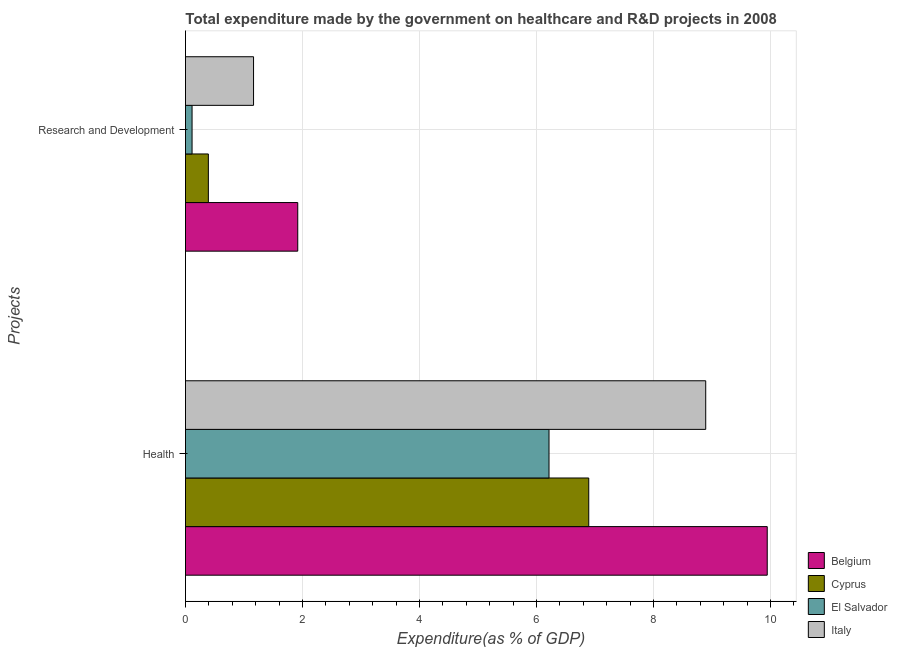How many groups of bars are there?
Offer a very short reply. 2. How many bars are there on the 2nd tick from the top?
Offer a very short reply. 4. How many bars are there on the 2nd tick from the bottom?
Provide a short and direct response. 4. What is the label of the 2nd group of bars from the top?
Your answer should be very brief. Health. What is the expenditure in healthcare in Belgium?
Make the answer very short. 9.94. Across all countries, what is the maximum expenditure in healthcare?
Your answer should be very brief. 9.94. Across all countries, what is the minimum expenditure in r&d?
Your response must be concise. 0.11. In which country was the expenditure in r&d maximum?
Give a very brief answer. Belgium. In which country was the expenditure in healthcare minimum?
Your answer should be compact. El Salvador. What is the total expenditure in healthcare in the graph?
Give a very brief answer. 31.94. What is the difference between the expenditure in r&d in Cyprus and that in Italy?
Keep it short and to the point. -0.77. What is the difference between the expenditure in healthcare in Cyprus and the expenditure in r&d in Belgium?
Your answer should be compact. 4.97. What is the average expenditure in healthcare per country?
Ensure brevity in your answer.  7.98. What is the difference between the expenditure in healthcare and expenditure in r&d in Belgium?
Provide a succinct answer. 8.02. In how many countries, is the expenditure in healthcare greater than 6 %?
Offer a terse response. 4. What is the ratio of the expenditure in r&d in Cyprus to that in Italy?
Give a very brief answer. 0.34. Is the expenditure in healthcare in Belgium less than that in Cyprus?
Make the answer very short. No. In how many countries, is the expenditure in healthcare greater than the average expenditure in healthcare taken over all countries?
Offer a terse response. 2. What does the 4th bar from the top in Research and Development represents?
Offer a very short reply. Belgium. What does the 1st bar from the bottom in Health represents?
Keep it short and to the point. Belgium. How many bars are there?
Offer a very short reply. 8. How many countries are there in the graph?
Keep it short and to the point. 4. What is the difference between two consecutive major ticks on the X-axis?
Your answer should be compact. 2. Are the values on the major ticks of X-axis written in scientific E-notation?
Your answer should be compact. No. How many legend labels are there?
Give a very brief answer. 4. What is the title of the graph?
Keep it short and to the point. Total expenditure made by the government on healthcare and R&D projects in 2008. What is the label or title of the X-axis?
Provide a short and direct response. Expenditure(as % of GDP). What is the label or title of the Y-axis?
Provide a short and direct response. Projects. What is the Expenditure(as % of GDP) in Belgium in Health?
Give a very brief answer. 9.94. What is the Expenditure(as % of GDP) of Cyprus in Health?
Your response must be concise. 6.89. What is the Expenditure(as % of GDP) in El Salvador in Health?
Your response must be concise. 6.21. What is the Expenditure(as % of GDP) of Italy in Health?
Ensure brevity in your answer.  8.89. What is the Expenditure(as % of GDP) of Belgium in Research and Development?
Offer a very short reply. 1.92. What is the Expenditure(as % of GDP) in Cyprus in Research and Development?
Give a very brief answer. 0.39. What is the Expenditure(as % of GDP) in El Salvador in Research and Development?
Your response must be concise. 0.11. What is the Expenditure(as % of GDP) in Italy in Research and Development?
Your answer should be compact. 1.16. Across all Projects, what is the maximum Expenditure(as % of GDP) in Belgium?
Your answer should be very brief. 9.94. Across all Projects, what is the maximum Expenditure(as % of GDP) of Cyprus?
Make the answer very short. 6.89. Across all Projects, what is the maximum Expenditure(as % of GDP) in El Salvador?
Make the answer very short. 6.21. Across all Projects, what is the maximum Expenditure(as % of GDP) of Italy?
Offer a very short reply. 8.89. Across all Projects, what is the minimum Expenditure(as % of GDP) in Belgium?
Ensure brevity in your answer.  1.92. Across all Projects, what is the minimum Expenditure(as % of GDP) in Cyprus?
Offer a very short reply. 0.39. Across all Projects, what is the minimum Expenditure(as % of GDP) of El Salvador?
Your response must be concise. 0.11. Across all Projects, what is the minimum Expenditure(as % of GDP) in Italy?
Make the answer very short. 1.16. What is the total Expenditure(as % of GDP) of Belgium in the graph?
Ensure brevity in your answer.  11.86. What is the total Expenditure(as % of GDP) of Cyprus in the graph?
Give a very brief answer. 7.28. What is the total Expenditure(as % of GDP) in El Salvador in the graph?
Your answer should be compact. 6.33. What is the total Expenditure(as % of GDP) in Italy in the graph?
Offer a very short reply. 10.05. What is the difference between the Expenditure(as % of GDP) of Belgium in Health and that in Research and Development?
Provide a succinct answer. 8.02. What is the difference between the Expenditure(as % of GDP) of Cyprus in Health and that in Research and Development?
Keep it short and to the point. 6.5. What is the difference between the Expenditure(as % of GDP) of El Salvador in Health and that in Research and Development?
Offer a very short reply. 6.1. What is the difference between the Expenditure(as % of GDP) of Italy in Health and that in Research and Development?
Give a very brief answer. 7.73. What is the difference between the Expenditure(as % of GDP) of Belgium in Health and the Expenditure(as % of GDP) of Cyprus in Research and Development?
Ensure brevity in your answer.  9.55. What is the difference between the Expenditure(as % of GDP) of Belgium in Health and the Expenditure(as % of GDP) of El Salvador in Research and Development?
Provide a succinct answer. 9.83. What is the difference between the Expenditure(as % of GDP) of Belgium in Health and the Expenditure(as % of GDP) of Italy in Research and Development?
Offer a very short reply. 8.78. What is the difference between the Expenditure(as % of GDP) of Cyprus in Health and the Expenditure(as % of GDP) of El Salvador in Research and Development?
Make the answer very short. 6.78. What is the difference between the Expenditure(as % of GDP) of Cyprus in Health and the Expenditure(as % of GDP) of Italy in Research and Development?
Give a very brief answer. 5.73. What is the difference between the Expenditure(as % of GDP) in El Salvador in Health and the Expenditure(as % of GDP) in Italy in Research and Development?
Give a very brief answer. 5.05. What is the average Expenditure(as % of GDP) of Belgium per Projects?
Give a very brief answer. 5.93. What is the average Expenditure(as % of GDP) of Cyprus per Projects?
Give a very brief answer. 3.64. What is the average Expenditure(as % of GDP) of El Salvador per Projects?
Offer a terse response. 3.16. What is the average Expenditure(as % of GDP) in Italy per Projects?
Your response must be concise. 5.03. What is the difference between the Expenditure(as % of GDP) of Belgium and Expenditure(as % of GDP) of Cyprus in Health?
Keep it short and to the point. 3.05. What is the difference between the Expenditure(as % of GDP) of Belgium and Expenditure(as % of GDP) of El Salvador in Health?
Your response must be concise. 3.73. What is the difference between the Expenditure(as % of GDP) of Belgium and Expenditure(as % of GDP) of Italy in Health?
Keep it short and to the point. 1.05. What is the difference between the Expenditure(as % of GDP) in Cyprus and Expenditure(as % of GDP) in El Salvador in Health?
Offer a terse response. 0.68. What is the difference between the Expenditure(as % of GDP) in Cyprus and Expenditure(as % of GDP) in Italy in Health?
Ensure brevity in your answer.  -2. What is the difference between the Expenditure(as % of GDP) of El Salvador and Expenditure(as % of GDP) of Italy in Health?
Offer a terse response. -2.68. What is the difference between the Expenditure(as % of GDP) of Belgium and Expenditure(as % of GDP) of Cyprus in Research and Development?
Your answer should be compact. 1.53. What is the difference between the Expenditure(as % of GDP) of Belgium and Expenditure(as % of GDP) of El Salvador in Research and Development?
Make the answer very short. 1.81. What is the difference between the Expenditure(as % of GDP) of Belgium and Expenditure(as % of GDP) of Italy in Research and Development?
Ensure brevity in your answer.  0.76. What is the difference between the Expenditure(as % of GDP) of Cyprus and Expenditure(as % of GDP) of El Salvador in Research and Development?
Offer a very short reply. 0.28. What is the difference between the Expenditure(as % of GDP) in Cyprus and Expenditure(as % of GDP) in Italy in Research and Development?
Ensure brevity in your answer.  -0.77. What is the difference between the Expenditure(as % of GDP) of El Salvador and Expenditure(as % of GDP) of Italy in Research and Development?
Your response must be concise. -1.05. What is the ratio of the Expenditure(as % of GDP) in Belgium in Health to that in Research and Development?
Give a very brief answer. 5.18. What is the ratio of the Expenditure(as % of GDP) in Cyprus in Health to that in Research and Development?
Make the answer very short. 17.63. What is the ratio of the Expenditure(as % of GDP) in El Salvador in Health to that in Research and Development?
Ensure brevity in your answer.  55.25. What is the ratio of the Expenditure(as % of GDP) of Italy in Health to that in Research and Development?
Your answer should be very brief. 7.64. What is the difference between the highest and the second highest Expenditure(as % of GDP) in Belgium?
Provide a short and direct response. 8.02. What is the difference between the highest and the second highest Expenditure(as % of GDP) of Cyprus?
Give a very brief answer. 6.5. What is the difference between the highest and the second highest Expenditure(as % of GDP) in El Salvador?
Provide a short and direct response. 6.1. What is the difference between the highest and the second highest Expenditure(as % of GDP) of Italy?
Make the answer very short. 7.73. What is the difference between the highest and the lowest Expenditure(as % of GDP) in Belgium?
Your answer should be compact. 8.02. What is the difference between the highest and the lowest Expenditure(as % of GDP) of Cyprus?
Your answer should be compact. 6.5. What is the difference between the highest and the lowest Expenditure(as % of GDP) in El Salvador?
Offer a very short reply. 6.1. What is the difference between the highest and the lowest Expenditure(as % of GDP) of Italy?
Ensure brevity in your answer.  7.73. 